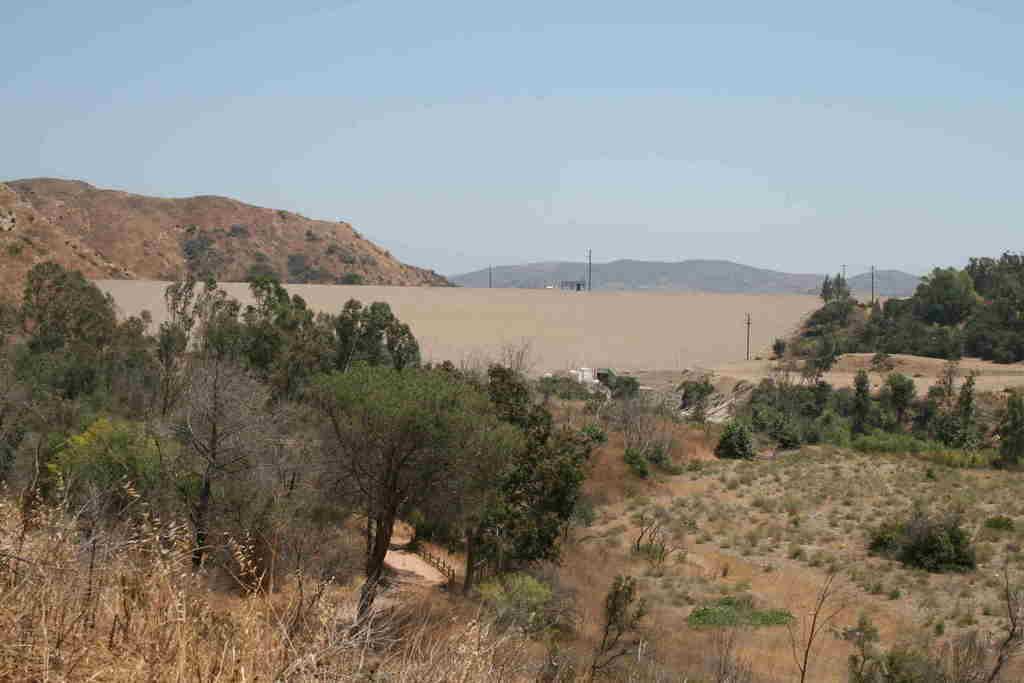Can you describe this image briefly? In this image at the bottom there are some trees, sand and some plants, and in the background there is sand and some poles, trees and mountains and objects. At the top there is sky. 